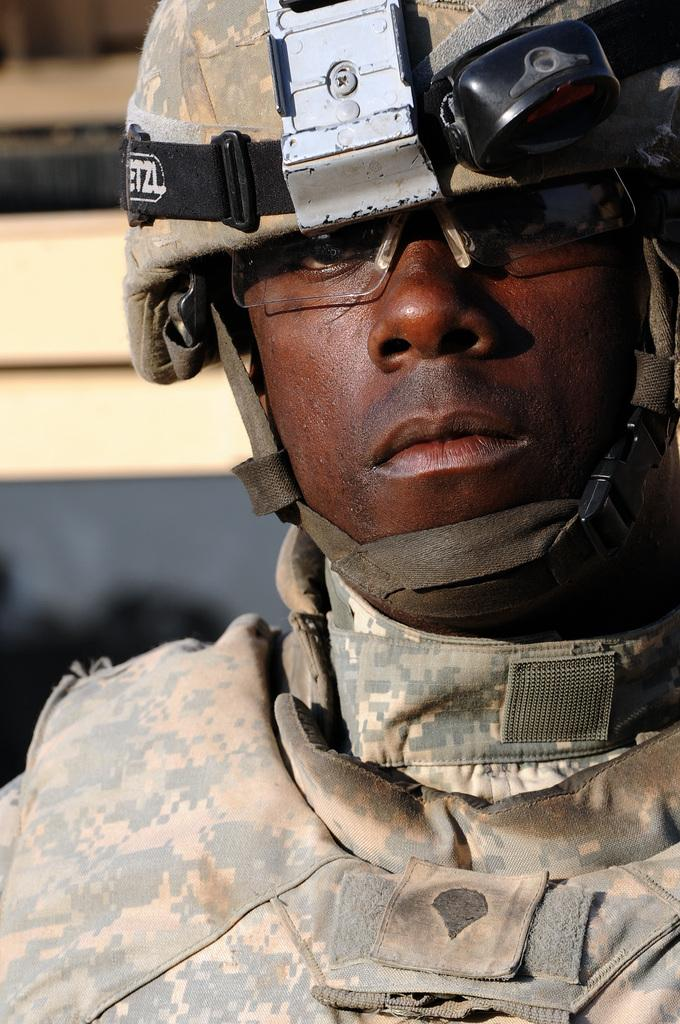What type of person is depicted in the picture? There is a soldier in the picture. What protective gear is the soldier wearing? The soldier is wearing a helmet and safety goggles on his eyes. What type of juice is the soldier holding in the picture? There is no juice present in the picture; the soldier is not holding any beverage. 